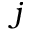<formula> <loc_0><loc_0><loc_500><loc_500>j</formula> 